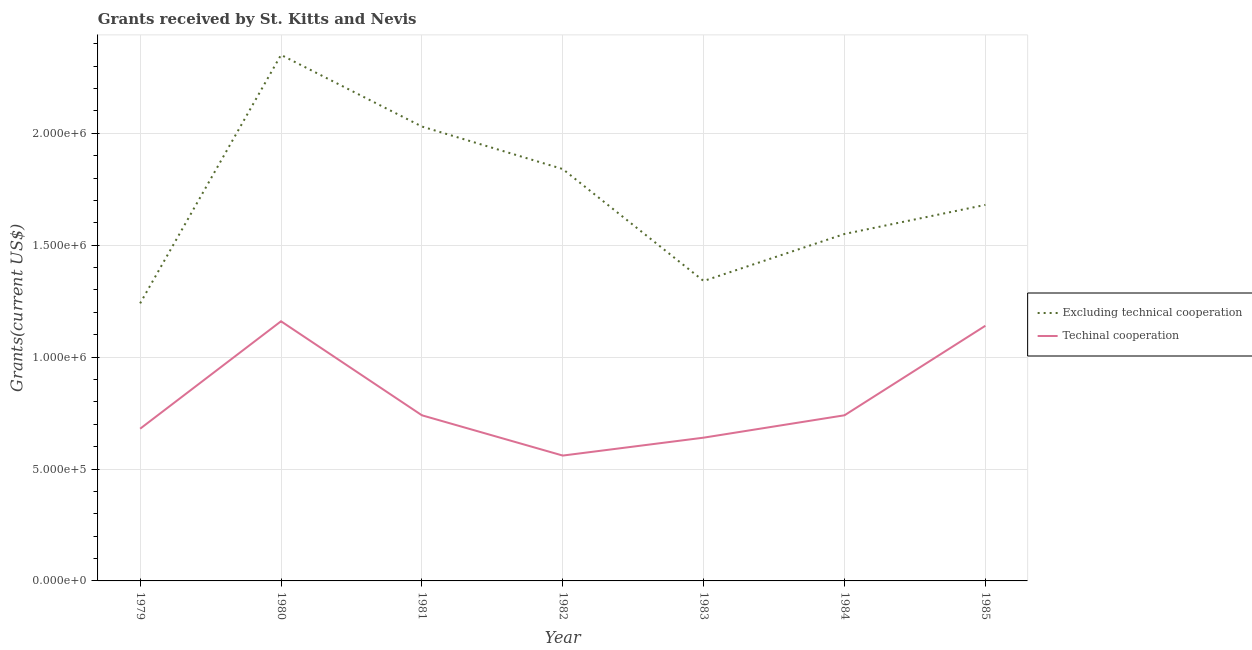What is the amount of grants received(excluding technical cooperation) in 1985?
Ensure brevity in your answer.  1.68e+06. Across all years, what is the maximum amount of grants received(including technical cooperation)?
Your answer should be very brief. 1.16e+06. Across all years, what is the minimum amount of grants received(including technical cooperation)?
Offer a terse response. 5.60e+05. In which year was the amount of grants received(excluding technical cooperation) maximum?
Make the answer very short. 1980. In which year was the amount of grants received(excluding technical cooperation) minimum?
Ensure brevity in your answer.  1979. What is the total amount of grants received(including technical cooperation) in the graph?
Ensure brevity in your answer.  5.66e+06. What is the difference between the amount of grants received(including technical cooperation) in 1982 and that in 1984?
Your answer should be very brief. -1.80e+05. What is the difference between the amount of grants received(excluding technical cooperation) in 1982 and the amount of grants received(including technical cooperation) in 1985?
Offer a very short reply. 7.00e+05. What is the average amount of grants received(excluding technical cooperation) per year?
Give a very brief answer. 1.72e+06. In the year 1985, what is the difference between the amount of grants received(including technical cooperation) and amount of grants received(excluding technical cooperation)?
Ensure brevity in your answer.  -5.40e+05. In how many years, is the amount of grants received(excluding technical cooperation) greater than 2100000 US$?
Ensure brevity in your answer.  1. What is the ratio of the amount of grants received(excluding technical cooperation) in 1980 to that in 1984?
Your answer should be compact. 1.52. What is the difference between the highest and the lowest amount of grants received(excluding technical cooperation)?
Ensure brevity in your answer.  1.11e+06. Is the sum of the amount of grants received(including technical cooperation) in 1981 and 1985 greater than the maximum amount of grants received(excluding technical cooperation) across all years?
Your answer should be compact. No. Does the amount of grants received(including technical cooperation) monotonically increase over the years?
Ensure brevity in your answer.  No. Is the amount of grants received(including technical cooperation) strictly less than the amount of grants received(excluding technical cooperation) over the years?
Provide a short and direct response. Yes. How many lines are there?
Give a very brief answer. 2. How many years are there in the graph?
Offer a terse response. 7. What is the difference between two consecutive major ticks on the Y-axis?
Ensure brevity in your answer.  5.00e+05. Does the graph contain any zero values?
Your answer should be compact. No. Where does the legend appear in the graph?
Offer a very short reply. Center right. What is the title of the graph?
Offer a very short reply. Grants received by St. Kitts and Nevis. Does "Non-pregnant women" appear as one of the legend labels in the graph?
Provide a succinct answer. No. What is the label or title of the Y-axis?
Provide a short and direct response. Grants(current US$). What is the Grants(current US$) in Excluding technical cooperation in 1979?
Make the answer very short. 1.24e+06. What is the Grants(current US$) in Techinal cooperation in 1979?
Make the answer very short. 6.80e+05. What is the Grants(current US$) of Excluding technical cooperation in 1980?
Make the answer very short. 2.35e+06. What is the Grants(current US$) of Techinal cooperation in 1980?
Give a very brief answer. 1.16e+06. What is the Grants(current US$) of Excluding technical cooperation in 1981?
Your answer should be compact. 2.03e+06. What is the Grants(current US$) in Techinal cooperation in 1981?
Offer a very short reply. 7.40e+05. What is the Grants(current US$) of Excluding technical cooperation in 1982?
Ensure brevity in your answer.  1.84e+06. What is the Grants(current US$) of Techinal cooperation in 1982?
Offer a very short reply. 5.60e+05. What is the Grants(current US$) of Excluding technical cooperation in 1983?
Your answer should be compact. 1.34e+06. What is the Grants(current US$) of Techinal cooperation in 1983?
Your answer should be compact. 6.40e+05. What is the Grants(current US$) in Excluding technical cooperation in 1984?
Your response must be concise. 1.55e+06. What is the Grants(current US$) of Techinal cooperation in 1984?
Provide a short and direct response. 7.40e+05. What is the Grants(current US$) in Excluding technical cooperation in 1985?
Offer a very short reply. 1.68e+06. What is the Grants(current US$) in Techinal cooperation in 1985?
Keep it short and to the point. 1.14e+06. Across all years, what is the maximum Grants(current US$) of Excluding technical cooperation?
Your response must be concise. 2.35e+06. Across all years, what is the maximum Grants(current US$) of Techinal cooperation?
Your answer should be very brief. 1.16e+06. Across all years, what is the minimum Grants(current US$) in Excluding technical cooperation?
Offer a terse response. 1.24e+06. Across all years, what is the minimum Grants(current US$) of Techinal cooperation?
Your answer should be very brief. 5.60e+05. What is the total Grants(current US$) in Excluding technical cooperation in the graph?
Your response must be concise. 1.20e+07. What is the total Grants(current US$) of Techinal cooperation in the graph?
Provide a short and direct response. 5.66e+06. What is the difference between the Grants(current US$) in Excluding technical cooperation in 1979 and that in 1980?
Your response must be concise. -1.11e+06. What is the difference between the Grants(current US$) of Techinal cooperation in 1979 and that in 1980?
Your answer should be compact. -4.80e+05. What is the difference between the Grants(current US$) of Excluding technical cooperation in 1979 and that in 1981?
Provide a succinct answer. -7.90e+05. What is the difference between the Grants(current US$) in Techinal cooperation in 1979 and that in 1981?
Offer a terse response. -6.00e+04. What is the difference between the Grants(current US$) of Excluding technical cooperation in 1979 and that in 1982?
Your answer should be compact. -6.00e+05. What is the difference between the Grants(current US$) in Excluding technical cooperation in 1979 and that in 1983?
Your response must be concise. -1.00e+05. What is the difference between the Grants(current US$) of Techinal cooperation in 1979 and that in 1983?
Offer a terse response. 4.00e+04. What is the difference between the Grants(current US$) in Excluding technical cooperation in 1979 and that in 1984?
Offer a very short reply. -3.10e+05. What is the difference between the Grants(current US$) in Excluding technical cooperation in 1979 and that in 1985?
Give a very brief answer. -4.40e+05. What is the difference between the Grants(current US$) in Techinal cooperation in 1979 and that in 1985?
Your answer should be very brief. -4.60e+05. What is the difference between the Grants(current US$) of Techinal cooperation in 1980 and that in 1981?
Give a very brief answer. 4.20e+05. What is the difference between the Grants(current US$) of Excluding technical cooperation in 1980 and that in 1982?
Your response must be concise. 5.10e+05. What is the difference between the Grants(current US$) in Techinal cooperation in 1980 and that in 1982?
Keep it short and to the point. 6.00e+05. What is the difference between the Grants(current US$) in Excluding technical cooperation in 1980 and that in 1983?
Your answer should be compact. 1.01e+06. What is the difference between the Grants(current US$) of Techinal cooperation in 1980 and that in 1983?
Offer a terse response. 5.20e+05. What is the difference between the Grants(current US$) of Excluding technical cooperation in 1980 and that in 1985?
Provide a succinct answer. 6.70e+05. What is the difference between the Grants(current US$) of Excluding technical cooperation in 1981 and that in 1983?
Ensure brevity in your answer.  6.90e+05. What is the difference between the Grants(current US$) in Techinal cooperation in 1981 and that in 1983?
Your response must be concise. 1.00e+05. What is the difference between the Grants(current US$) of Excluding technical cooperation in 1981 and that in 1984?
Provide a short and direct response. 4.80e+05. What is the difference between the Grants(current US$) in Techinal cooperation in 1981 and that in 1984?
Offer a very short reply. 0. What is the difference between the Grants(current US$) in Techinal cooperation in 1981 and that in 1985?
Offer a terse response. -4.00e+05. What is the difference between the Grants(current US$) in Techinal cooperation in 1982 and that in 1983?
Keep it short and to the point. -8.00e+04. What is the difference between the Grants(current US$) in Excluding technical cooperation in 1982 and that in 1984?
Make the answer very short. 2.90e+05. What is the difference between the Grants(current US$) in Excluding technical cooperation in 1982 and that in 1985?
Offer a very short reply. 1.60e+05. What is the difference between the Grants(current US$) of Techinal cooperation in 1982 and that in 1985?
Ensure brevity in your answer.  -5.80e+05. What is the difference between the Grants(current US$) of Techinal cooperation in 1983 and that in 1984?
Make the answer very short. -1.00e+05. What is the difference between the Grants(current US$) of Techinal cooperation in 1983 and that in 1985?
Keep it short and to the point. -5.00e+05. What is the difference between the Grants(current US$) of Techinal cooperation in 1984 and that in 1985?
Your response must be concise. -4.00e+05. What is the difference between the Grants(current US$) of Excluding technical cooperation in 1979 and the Grants(current US$) of Techinal cooperation in 1980?
Offer a terse response. 8.00e+04. What is the difference between the Grants(current US$) in Excluding technical cooperation in 1979 and the Grants(current US$) in Techinal cooperation in 1982?
Give a very brief answer. 6.80e+05. What is the difference between the Grants(current US$) in Excluding technical cooperation in 1979 and the Grants(current US$) in Techinal cooperation in 1983?
Provide a succinct answer. 6.00e+05. What is the difference between the Grants(current US$) of Excluding technical cooperation in 1980 and the Grants(current US$) of Techinal cooperation in 1981?
Your response must be concise. 1.61e+06. What is the difference between the Grants(current US$) in Excluding technical cooperation in 1980 and the Grants(current US$) in Techinal cooperation in 1982?
Offer a terse response. 1.79e+06. What is the difference between the Grants(current US$) of Excluding technical cooperation in 1980 and the Grants(current US$) of Techinal cooperation in 1983?
Provide a succinct answer. 1.71e+06. What is the difference between the Grants(current US$) of Excluding technical cooperation in 1980 and the Grants(current US$) of Techinal cooperation in 1984?
Your answer should be very brief. 1.61e+06. What is the difference between the Grants(current US$) in Excluding technical cooperation in 1980 and the Grants(current US$) in Techinal cooperation in 1985?
Your answer should be compact. 1.21e+06. What is the difference between the Grants(current US$) in Excluding technical cooperation in 1981 and the Grants(current US$) in Techinal cooperation in 1982?
Provide a succinct answer. 1.47e+06. What is the difference between the Grants(current US$) of Excluding technical cooperation in 1981 and the Grants(current US$) of Techinal cooperation in 1983?
Your answer should be very brief. 1.39e+06. What is the difference between the Grants(current US$) in Excluding technical cooperation in 1981 and the Grants(current US$) in Techinal cooperation in 1984?
Provide a short and direct response. 1.29e+06. What is the difference between the Grants(current US$) of Excluding technical cooperation in 1981 and the Grants(current US$) of Techinal cooperation in 1985?
Make the answer very short. 8.90e+05. What is the difference between the Grants(current US$) in Excluding technical cooperation in 1982 and the Grants(current US$) in Techinal cooperation in 1983?
Your response must be concise. 1.20e+06. What is the difference between the Grants(current US$) in Excluding technical cooperation in 1982 and the Grants(current US$) in Techinal cooperation in 1984?
Give a very brief answer. 1.10e+06. What is the difference between the Grants(current US$) of Excluding technical cooperation in 1982 and the Grants(current US$) of Techinal cooperation in 1985?
Provide a short and direct response. 7.00e+05. What is the difference between the Grants(current US$) of Excluding technical cooperation in 1983 and the Grants(current US$) of Techinal cooperation in 1984?
Ensure brevity in your answer.  6.00e+05. What is the average Grants(current US$) of Excluding technical cooperation per year?
Your answer should be compact. 1.72e+06. What is the average Grants(current US$) in Techinal cooperation per year?
Keep it short and to the point. 8.09e+05. In the year 1979, what is the difference between the Grants(current US$) of Excluding technical cooperation and Grants(current US$) of Techinal cooperation?
Give a very brief answer. 5.60e+05. In the year 1980, what is the difference between the Grants(current US$) in Excluding technical cooperation and Grants(current US$) in Techinal cooperation?
Your answer should be very brief. 1.19e+06. In the year 1981, what is the difference between the Grants(current US$) of Excluding technical cooperation and Grants(current US$) of Techinal cooperation?
Your answer should be compact. 1.29e+06. In the year 1982, what is the difference between the Grants(current US$) in Excluding technical cooperation and Grants(current US$) in Techinal cooperation?
Ensure brevity in your answer.  1.28e+06. In the year 1983, what is the difference between the Grants(current US$) of Excluding technical cooperation and Grants(current US$) of Techinal cooperation?
Make the answer very short. 7.00e+05. In the year 1984, what is the difference between the Grants(current US$) in Excluding technical cooperation and Grants(current US$) in Techinal cooperation?
Ensure brevity in your answer.  8.10e+05. In the year 1985, what is the difference between the Grants(current US$) of Excluding technical cooperation and Grants(current US$) of Techinal cooperation?
Offer a terse response. 5.40e+05. What is the ratio of the Grants(current US$) of Excluding technical cooperation in 1979 to that in 1980?
Offer a terse response. 0.53. What is the ratio of the Grants(current US$) of Techinal cooperation in 1979 to that in 1980?
Give a very brief answer. 0.59. What is the ratio of the Grants(current US$) of Excluding technical cooperation in 1979 to that in 1981?
Your response must be concise. 0.61. What is the ratio of the Grants(current US$) of Techinal cooperation in 1979 to that in 1981?
Your answer should be compact. 0.92. What is the ratio of the Grants(current US$) of Excluding technical cooperation in 1979 to that in 1982?
Give a very brief answer. 0.67. What is the ratio of the Grants(current US$) in Techinal cooperation in 1979 to that in 1982?
Make the answer very short. 1.21. What is the ratio of the Grants(current US$) of Excluding technical cooperation in 1979 to that in 1983?
Provide a short and direct response. 0.93. What is the ratio of the Grants(current US$) in Excluding technical cooperation in 1979 to that in 1984?
Offer a terse response. 0.8. What is the ratio of the Grants(current US$) of Techinal cooperation in 1979 to that in 1984?
Your answer should be compact. 0.92. What is the ratio of the Grants(current US$) of Excluding technical cooperation in 1979 to that in 1985?
Offer a very short reply. 0.74. What is the ratio of the Grants(current US$) in Techinal cooperation in 1979 to that in 1985?
Offer a very short reply. 0.6. What is the ratio of the Grants(current US$) in Excluding technical cooperation in 1980 to that in 1981?
Offer a very short reply. 1.16. What is the ratio of the Grants(current US$) of Techinal cooperation in 1980 to that in 1981?
Keep it short and to the point. 1.57. What is the ratio of the Grants(current US$) in Excluding technical cooperation in 1980 to that in 1982?
Provide a short and direct response. 1.28. What is the ratio of the Grants(current US$) of Techinal cooperation in 1980 to that in 1982?
Your answer should be compact. 2.07. What is the ratio of the Grants(current US$) in Excluding technical cooperation in 1980 to that in 1983?
Your answer should be compact. 1.75. What is the ratio of the Grants(current US$) in Techinal cooperation in 1980 to that in 1983?
Offer a very short reply. 1.81. What is the ratio of the Grants(current US$) in Excluding technical cooperation in 1980 to that in 1984?
Offer a terse response. 1.52. What is the ratio of the Grants(current US$) of Techinal cooperation in 1980 to that in 1984?
Your response must be concise. 1.57. What is the ratio of the Grants(current US$) of Excluding technical cooperation in 1980 to that in 1985?
Offer a terse response. 1.4. What is the ratio of the Grants(current US$) in Techinal cooperation in 1980 to that in 1985?
Provide a succinct answer. 1.02. What is the ratio of the Grants(current US$) in Excluding technical cooperation in 1981 to that in 1982?
Keep it short and to the point. 1.1. What is the ratio of the Grants(current US$) in Techinal cooperation in 1981 to that in 1982?
Provide a succinct answer. 1.32. What is the ratio of the Grants(current US$) of Excluding technical cooperation in 1981 to that in 1983?
Give a very brief answer. 1.51. What is the ratio of the Grants(current US$) in Techinal cooperation in 1981 to that in 1983?
Offer a terse response. 1.16. What is the ratio of the Grants(current US$) of Excluding technical cooperation in 1981 to that in 1984?
Your response must be concise. 1.31. What is the ratio of the Grants(current US$) of Techinal cooperation in 1981 to that in 1984?
Your answer should be compact. 1. What is the ratio of the Grants(current US$) in Excluding technical cooperation in 1981 to that in 1985?
Provide a short and direct response. 1.21. What is the ratio of the Grants(current US$) in Techinal cooperation in 1981 to that in 1985?
Make the answer very short. 0.65. What is the ratio of the Grants(current US$) in Excluding technical cooperation in 1982 to that in 1983?
Provide a short and direct response. 1.37. What is the ratio of the Grants(current US$) in Techinal cooperation in 1982 to that in 1983?
Make the answer very short. 0.88. What is the ratio of the Grants(current US$) in Excluding technical cooperation in 1982 to that in 1984?
Your response must be concise. 1.19. What is the ratio of the Grants(current US$) in Techinal cooperation in 1982 to that in 1984?
Your answer should be compact. 0.76. What is the ratio of the Grants(current US$) of Excluding technical cooperation in 1982 to that in 1985?
Provide a short and direct response. 1.1. What is the ratio of the Grants(current US$) of Techinal cooperation in 1982 to that in 1985?
Your response must be concise. 0.49. What is the ratio of the Grants(current US$) in Excluding technical cooperation in 1983 to that in 1984?
Offer a terse response. 0.86. What is the ratio of the Grants(current US$) of Techinal cooperation in 1983 to that in 1984?
Provide a short and direct response. 0.86. What is the ratio of the Grants(current US$) of Excluding technical cooperation in 1983 to that in 1985?
Your answer should be very brief. 0.8. What is the ratio of the Grants(current US$) in Techinal cooperation in 1983 to that in 1985?
Your answer should be very brief. 0.56. What is the ratio of the Grants(current US$) in Excluding technical cooperation in 1984 to that in 1985?
Give a very brief answer. 0.92. What is the ratio of the Grants(current US$) of Techinal cooperation in 1984 to that in 1985?
Provide a succinct answer. 0.65. What is the difference between the highest and the second highest Grants(current US$) in Excluding technical cooperation?
Provide a short and direct response. 3.20e+05. What is the difference between the highest and the second highest Grants(current US$) in Techinal cooperation?
Ensure brevity in your answer.  2.00e+04. What is the difference between the highest and the lowest Grants(current US$) in Excluding technical cooperation?
Provide a short and direct response. 1.11e+06. 